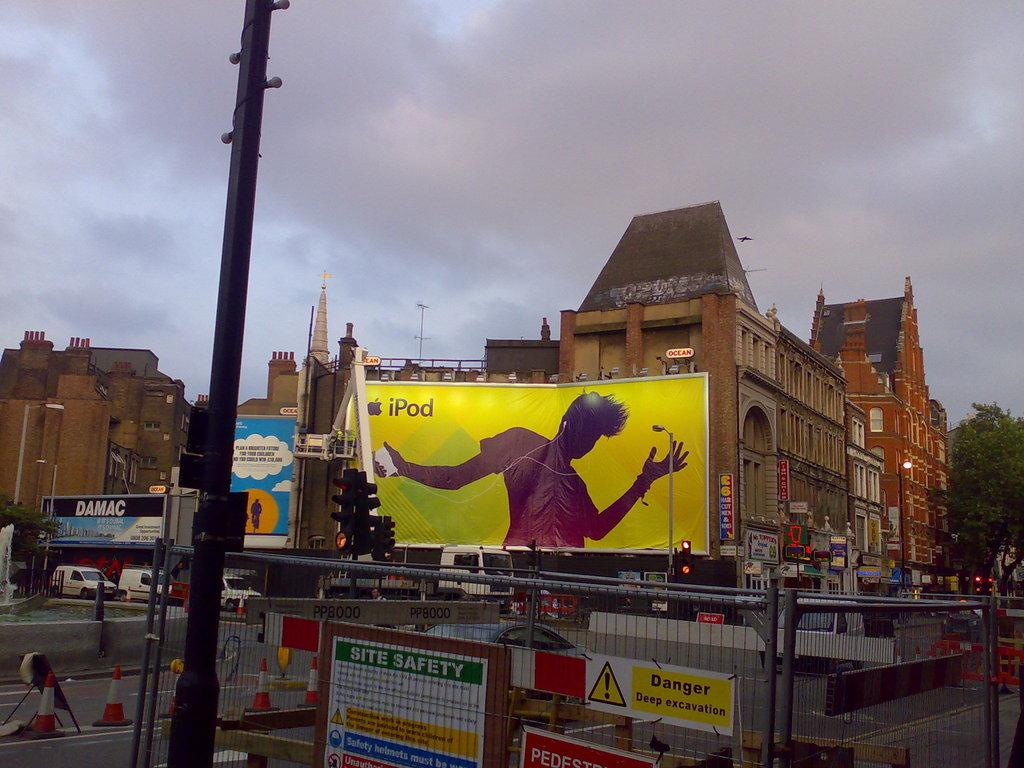<image>
Write a terse but informative summary of the picture. A bill board in bright yellow advertises an iPod. 